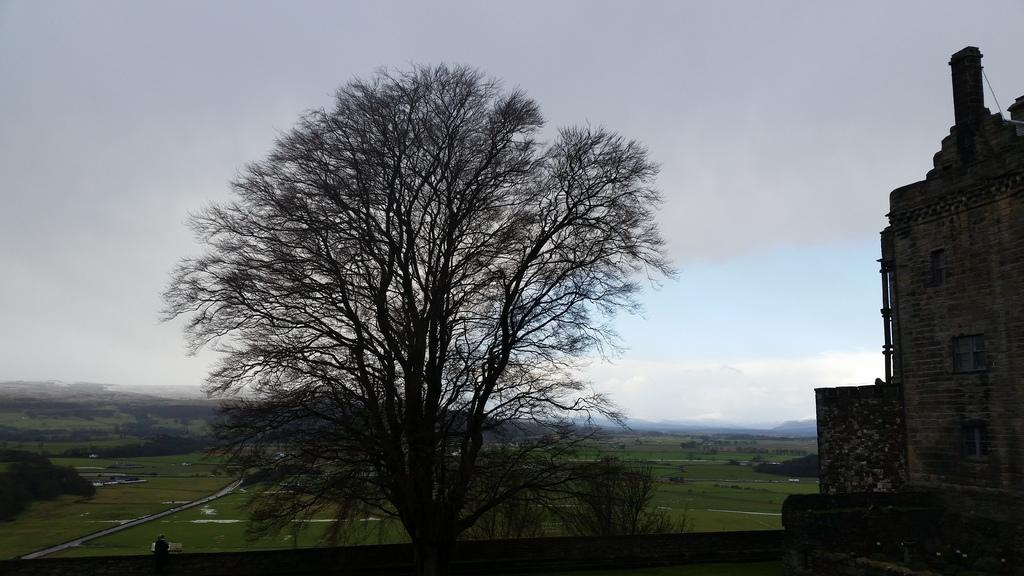What type of vegetation is in the image? There is a tree in the image. What type of structure is also present in the image? There is a building in the image. Where are the tree and building located in relation to the image? The tree and building are in the front of the image. What can be seen in the background of the image? There is grass and trees in the background of the image. What is visible at the top of the image of the image? The sky is visible at the top of the image. What type of fruit is growing on the quince tree in the image? There is no quince tree present in the image; it features a tree, but the type of tree is not specified. How does the harmony between the tree and building contribute to the overall aesthetic of the image? The image does not mention harmony or any aesthetic qualities related to the tree and building; it simply presents them as separate elements in the scene. 